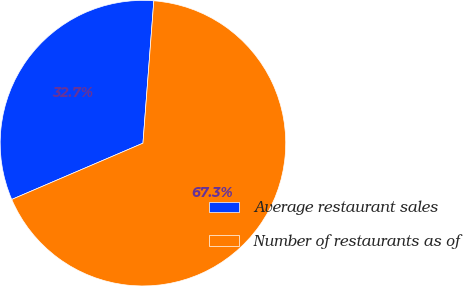Convert chart to OTSL. <chart><loc_0><loc_0><loc_500><loc_500><pie_chart><fcel>Average restaurant sales<fcel>Number of restaurants as of<nl><fcel>32.66%<fcel>67.34%<nl></chart> 